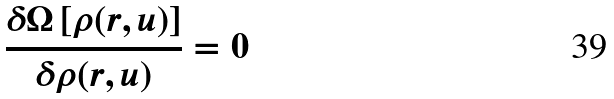Convert formula to latex. <formula><loc_0><loc_0><loc_500><loc_500>\frac { \delta \Omega \left [ \rho ( r , u ) \right ] } { \delta \rho ( r , u ) } = 0</formula> 